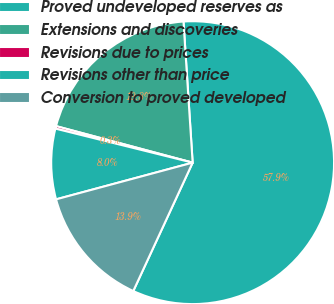Convert chart to OTSL. <chart><loc_0><loc_0><loc_500><loc_500><pie_chart><fcel>Proved undeveloped reserves as<fcel>Extensions and discoveries<fcel>Revisions due to prices<fcel>Revisions other than price<fcel>Conversion to proved developed<nl><fcel>57.93%<fcel>19.81%<fcel>0.29%<fcel>8.05%<fcel>13.93%<nl></chart> 